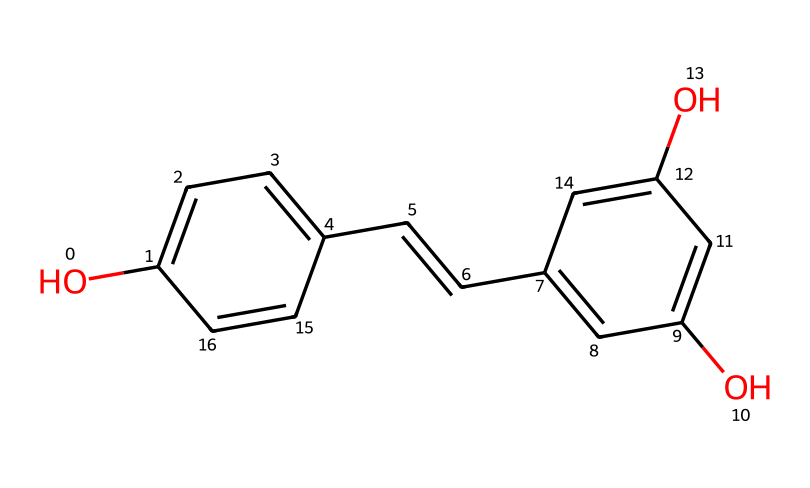What is the molecular formula of resveratrol? To determine the molecular formula from the SMILES representation, we identify the groups of atoms present. The structure indicates the presence of carbon (C), hydrogen (H), and oxygen (O). Counting the unique atoms: 14 carbons, 12 hydrogens, and 4 oxygens gives us the formula C14H12O4.
Answer: C14H12O4 How many hydroxyl (-OH) groups are present in the structure? Observing the structure reveals two -OH groups (indicated by the letters 'O' connected to carbon atoms). Each -OH group contributes to the antioxidant properties of the compound. Counting the number of hydroxyl groups gives us two.
Answer: 2 What type of compound is resveratrol classified as? Based on the visual representation and the presence of multiple aromatic rings, as well as the hydroxyl groups, this chemical is classified as a polyphenol. This class of compounds is typical for many antioxidants and features multiple phenolic structures.
Answer: polyphenol What functional groups can be identified in the structure of resveratrol? Analyzing the structure, we can see the presence of aromatic rings and hydroxyl groups. Aromatic rings are evident from the cyclic carbon arrangements, and the -OH groups classified as hydroxyl groups represent the functional aspects contributing to its chemical behavior. Thus, the main functional groups are hydroxyl and aromatic.
Answer: hydroxyl and aromatic How many double bonds are present in resveratrol? By examining the connections between carbon atoms in the structure, we identify one double bond in the alkene segment (C=C) between two carbon atoms. This feature contributes to the overall structure of the compound and its reactivity as an antioxidant.
Answer: 1 What type of antioxidant properties does resveratrol exhibit? Resveratrol is recognized for its ability to scavenge free radicals due to the hydroxyl groups present in its structure. These groups allow it to donate electrons, thus stabilizing free radicals and preventing oxidative stress in biological systems. This property classifies it as a protective antioxidant.
Answer: protective antioxidant 